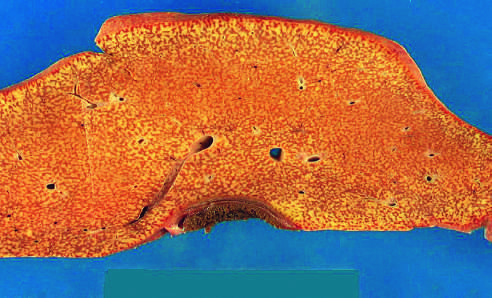how much does the liver weigh?
Answer the question using a single word or phrase. 700 g 